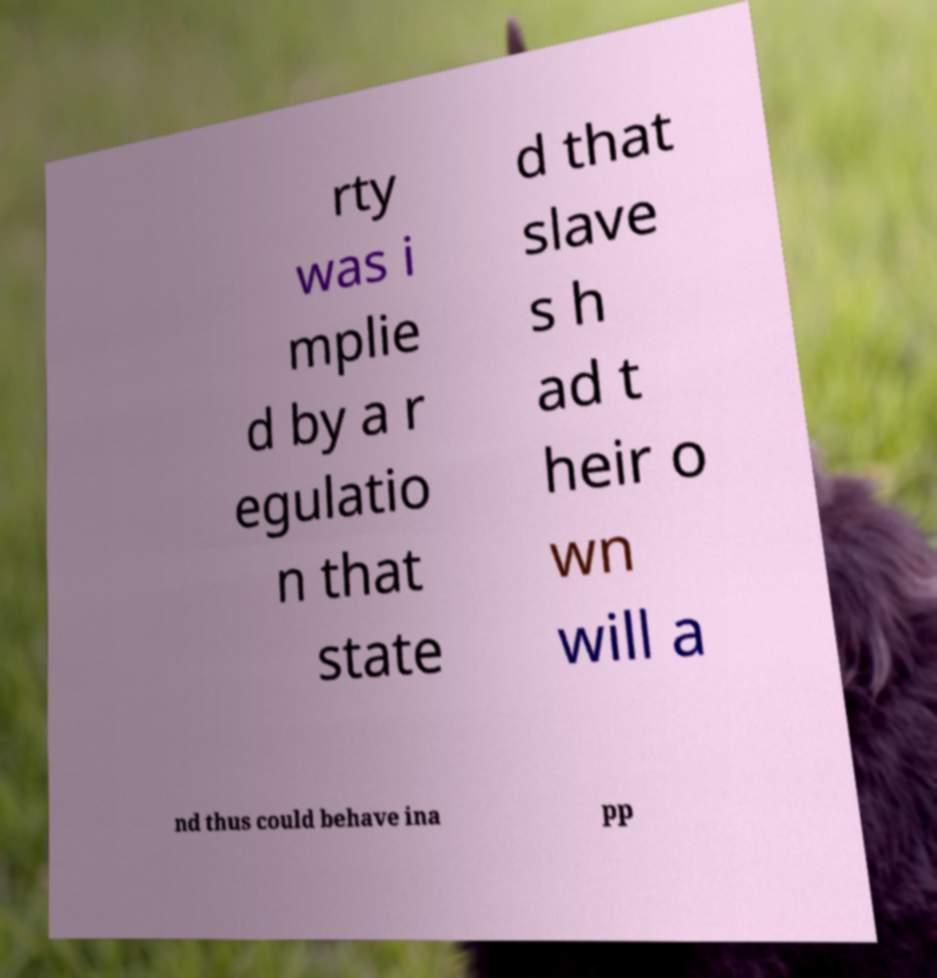For documentation purposes, I need the text within this image transcribed. Could you provide that? rty was i mplie d by a r egulatio n that state d that slave s h ad t heir o wn will a nd thus could behave ina pp 